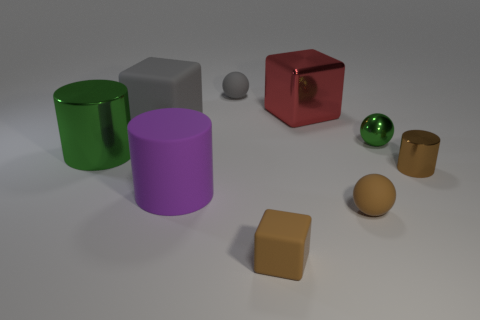What color is the block that is in front of the big gray cube?
Your answer should be very brief. Brown. The small matte object that is behind the brown thing that is behind the purple object is what shape?
Your answer should be compact. Sphere. Is the gray block made of the same material as the big cylinder to the right of the gray matte cube?
Ensure brevity in your answer.  Yes. There is a small object that is the same color as the big shiny cylinder; what shape is it?
Ensure brevity in your answer.  Sphere. What number of green metallic objects are the same size as the red cube?
Provide a succinct answer. 1. Is the number of green metal spheres behind the metal block less than the number of purple cylinders?
Provide a succinct answer. Yes. What number of things are in front of the tiny brown rubber ball?
Provide a short and direct response. 1. There is a block that is behind the gray matte thing on the left side of the tiny rubber object that is behind the green cylinder; how big is it?
Your answer should be very brief. Large. Is the shape of the red object the same as the tiny rubber object behind the tiny cylinder?
Make the answer very short. No. There is a green cylinder that is made of the same material as the brown cylinder; what is its size?
Your answer should be compact. Large. 